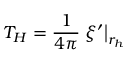<formula> <loc_0><loc_0><loc_500><loc_500>T _ { H } = \frac { 1 } { 4 \pi } \xi ^ { \prime } \right | _ { r _ { h } }</formula> 